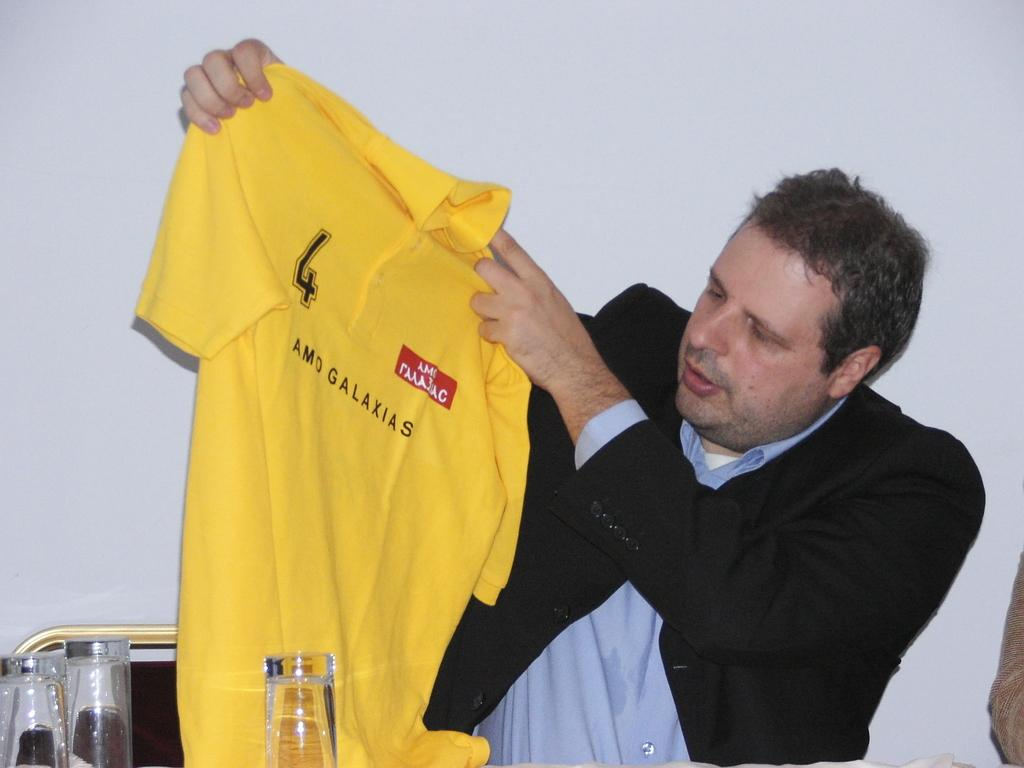<image>
Provide a brief description of the given image. A man in a blazer holding up a yellow shirt that has the number four on the shoulder area. 